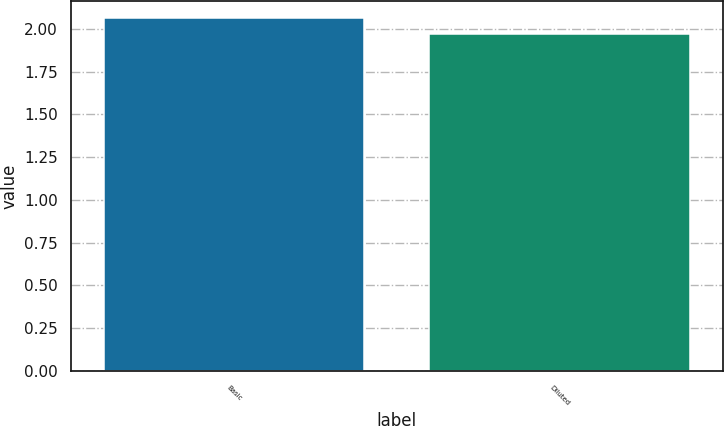Convert chart to OTSL. <chart><loc_0><loc_0><loc_500><loc_500><bar_chart><fcel>Basic<fcel>Diluted<nl><fcel>2.06<fcel>1.97<nl></chart> 